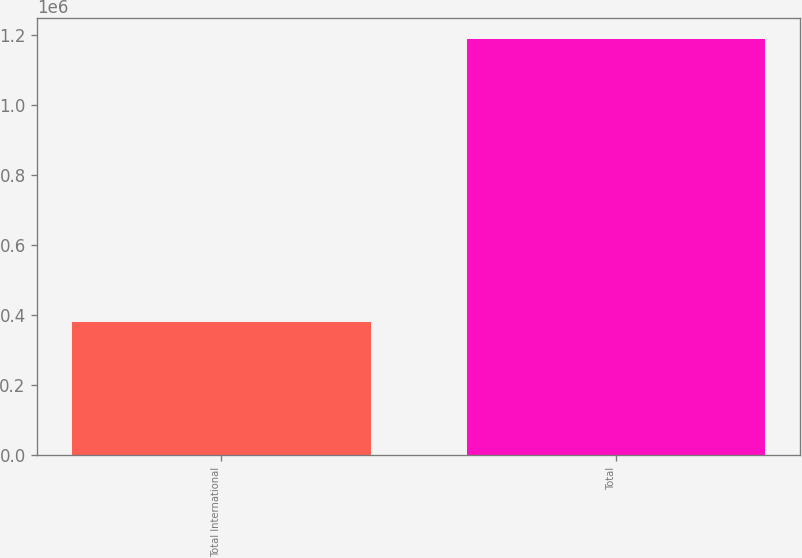Convert chart. <chart><loc_0><loc_0><loc_500><loc_500><bar_chart><fcel>Total International<fcel>Total<nl><fcel>382028<fcel>1.1906e+06<nl></chart> 